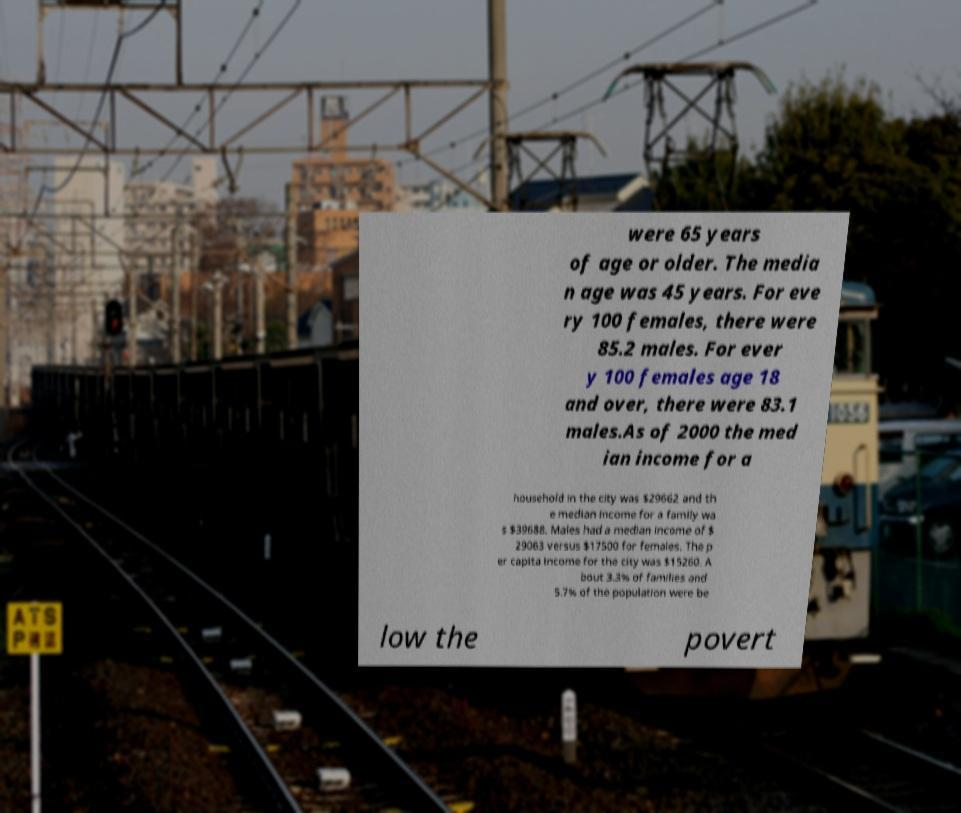What might the full text at the bottom of the paper signify in the context of the wider image? The text at the bottom, although partially obscured, mentions 'poverty'. This suggests that the statistics being presented are discussing the economic challenges within the area. The context of a cityscape further associates these statistics with urban socioeconomic dynamics. 